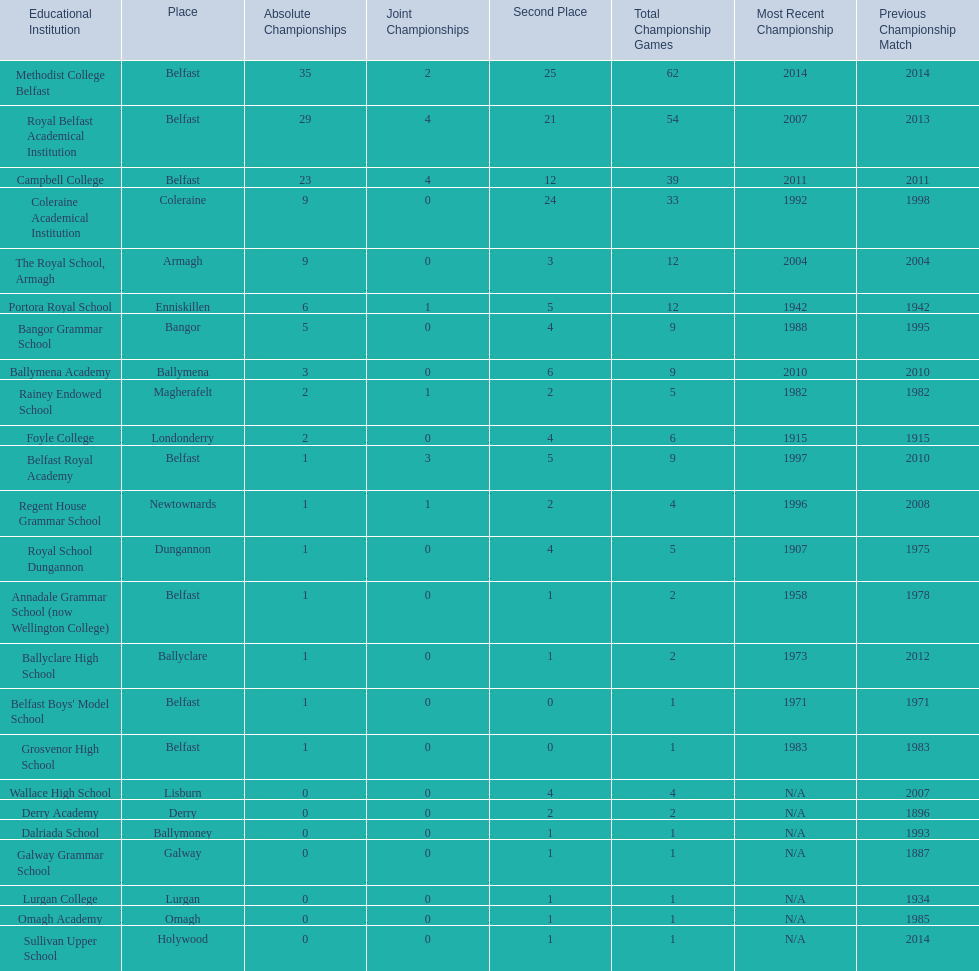What were all of the school names? Methodist College Belfast, Royal Belfast Academical Institution, Campbell College, Coleraine Academical Institution, The Royal School, Armagh, Portora Royal School, Bangor Grammar School, Ballymena Academy, Rainey Endowed School, Foyle College, Belfast Royal Academy, Regent House Grammar School, Royal School Dungannon, Annadale Grammar School (now Wellington College), Ballyclare High School, Belfast Boys' Model School, Grosvenor High School, Wallace High School, Derry Academy, Dalriada School, Galway Grammar School, Lurgan College, Omagh Academy, Sullivan Upper School. How many outright titles did they achieve? 35, 29, 23, 9, 9, 6, 5, 3, 2, 2, 1, 1, 1, 1, 1, 1, 1, 0, 0, 0, 0, 0, 0, 0. And how many did coleraine academical institution receive? 9. Which other school had the same number of outright titles? The Royal School, Armagh. 